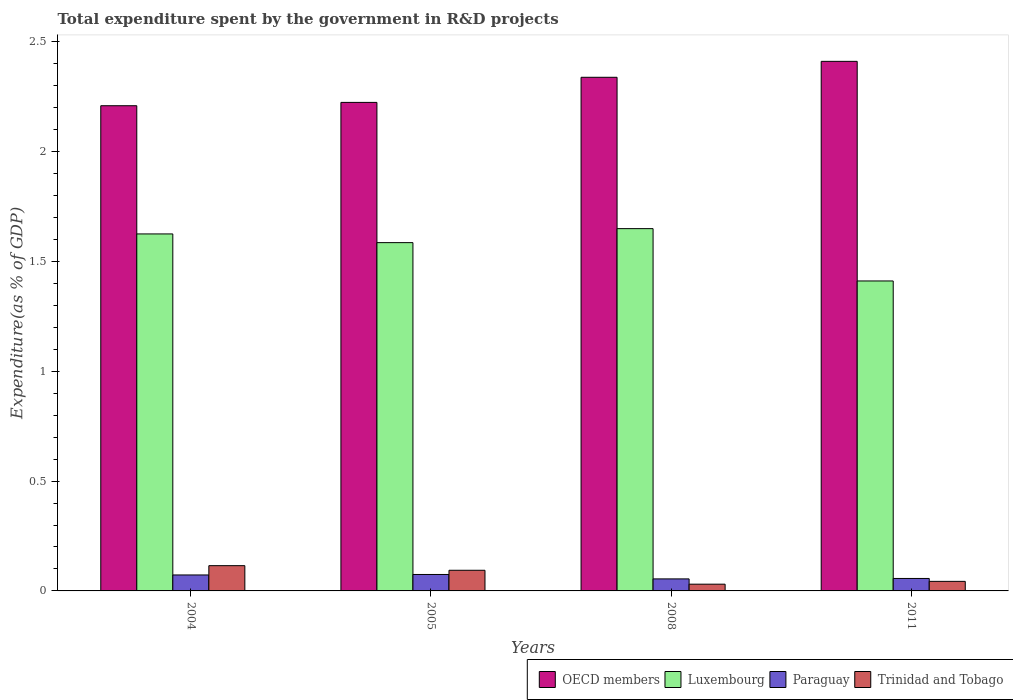How many different coloured bars are there?
Offer a very short reply. 4. How many groups of bars are there?
Your answer should be very brief. 4. How many bars are there on the 1st tick from the left?
Provide a short and direct response. 4. What is the label of the 3rd group of bars from the left?
Your answer should be very brief. 2008. In how many cases, is the number of bars for a given year not equal to the number of legend labels?
Your response must be concise. 0. What is the total expenditure spent by the government in R&D projects in Trinidad and Tobago in 2011?
Offer a very short reply. 0.04. Across all years, what is the maximum total expenditure spent by the government in R&D projects in Trinidad and Tobago?
Make the answer very short. 0.11. Across all years, what is the minimum total expenditure spent by the government in R&D projects in Trinidad and Tobago?
Keep it short and to the point. 0.03. In which year was the total expenditure spent by the government in R&D projects in Luxembourg maximum?
Your answer should be compact. 2008. In which year was the total expenditure spent by the government in R&D projects in Luxembourg minimum?
Provide a succinct answer. 2011. What is the total total expenditure spent by the government in R&D projects in Trinidad and Tobago in the graph?
Keep it short and to the point. 0.28. What is the difference between the total expenditure spent by the government in R&D projects in Trinidad and Tobago in 2004 and that in 2008?
Make the answer very short. 0.08. What is the difference between the total expenditure spent by the government in R&D projects in Paraguay in 2005 and the total expenditure spent by the government in R&D projects in Luxembourg in 2004?
Your answer should be compact. -1.55. What is the average total expenditure spent by the government in R&D projects in Paraguay per year?
Offer a terse response. 0.06. In the year 2008, what is the difference between the total expenditure spent by the government in R&D projects in Luxembourg and total expenditure spent by the government in R&D projects in OECD members?
Provide a short and direct response. -0.69. What is the ratio of the total expenditure spent by the government in R&D projects in Trinidad and Tobago in 2005 to that in 2008?
Make the answer very short. 3.06. Is the total expenditure spent by the government in R&D projects in OECD members in 2004 less than that in 2008?
Make the answer very short. Yes. Is the difference between the total expenditure spent by the government in R&D projects in Luxembourg in 2004 and 2008 greater than the difference between the total expenditure spent by the government in R&D projects in OECD members in 2004 and 2008?
Give a very brief answer. Yes. What is the difference between the highest and the second highest total expenditure spent by the government in R&D projects in Trinidad and Tobago?
Provide a succinct answer. 0.02. What is the difference between the highest and the lowest total expenditure spent by the government in R&D projects in Trinidad and Tobago?
Keep it short and to the point. 0.08. Is it the case that in every year, the sum of the total expenditure spent by the government in R&D projects in Luxembourg and total expenditure spent by the government in R&D projects in Paraguay is greater than the sum of total expenditure spent by the government in R&D projects in OECD members and total expenditure spent by the government in R&D projects in Trinidad and Tobago?
Ensure brevity in your answer.  No. What does the 4th bar from the left in 2005 represents?
Offer a terse response. Trinidad and Tobago. What does the 2nd bar from the right in 2011 represents?
Give a very brief answer. Paraguay. How many bars are there?
Your answer should be very brief. 16. Does the graph contain any zero values?
Keep it short and to the point. No. How many legend labels are there?
Your answer should be very brief. 4. How are the legend labels stacked?
Offer a terse response. Horizontal. What is the title of the graph?
Provide a short and direct response. Total expenditure spent by the government in R&D projects. Does "Uzbekistan" appear as one of the legend labels in the graph?
Offer a very short reply. No. What is the label or title of the X-axis?
Provide a succinct answer. Years. What is the label or title of the Y-axis?
Your answer should be very brief. Expenditure(as % of GDP). What is the Expenditure(as % of GDP) in OECD members in 2004?
Your answer should be very brief. 2.21. What is the Expenditure(as % of GDP) in Luxembourg in 2004?
Your answer should be compact. 1.62. What is the Expenditure(as % of GDP) of Paraguay in 2004?
Offer a very short reply. 0.07. What is the Expenditure(as % of GDP) in Trinidad and Tobago in 2004?
Offer a very short reply. 0.11. What is the Expenditure(as % of GDP) of OECD members in 2005?
Provide a short and direct response. 2.22. What is the Expenditure(as % of GDP) of Luxembourg in 2005?
Make the answer very short. 1.59. What is the Expenditure(as % of GDP) in Paraguay in 2005?
Make the answer very short. 0.07. What is the Expenditure(as % of GDP) in Trinidad and Tobago in 2005?
Provide a succinct answer. 0.09. What is the Expenditure(as % of GDP) of OECD members in 2008?
Provide a succinct answer. 2.34. What is the Expenditure(as % of GDP) in Luxembourg in 2008?
Your answer should be compact. 1.65. What is the Expenditure(as % of GDP) in Paraguay in 2008?
Your answer should be compact. 0.05. What is the Expenditure(as % of GDP) of Trinidad and Tobago in 2008?
Your answer should be very brief. 0.03. What is the Expenditure(as % of GDP) in OECD members in 2011?
Offer a terse response. 2.41. What is the Expenditure(as % of GDP) in Luxembourg in 2011?
Your answer should be compact. 1.41. What is the Expenditure(as % of GDP) in Paraguay in 2011?
Make the answer very short. 0.06. What is the Expenditure(as % of GDP) in Trinidad and Tobago in 2011?
Keep it short and to the point. 0.04. Across all years, what is the maximum Expenditure(as % of GDP) in OECD members?
Provide a succinct answer. 2.41. Across all years, what is the maximum Expenditure(as % of GDP) of Luxembourg?
Offer a very short reply. 1.65. Across all years, what is the maximum Expenditure(as % of GDP) in Paraguay?
Offer a terse response. 0.07. Across all years, what is the maximum Expenditure(as % of GDP) of Trinidad and Tobago?
Your answer should be compact. 0.11. Across all years, what is the minimum Expenditure(as % of GDP) in OECD members?
Your answer should be compact. 2.21. Across all years, what is the minimum Expenditure(as % of GDP) of Luxembourg?
Your answer should be very brief. 1.41. Across all years, what is the minimum Expenditure(as % of GDP) of Paraguay?
Keep it short and to the point. 0.05. Across all years, what is the minimum Expenditure(as % of GDP) of Trinidad and Tobago?
Provide a succinct answer. 0.03. What is the total Expenditure(as % of GDP) of OECD members in the graph?
Give a very brief answer. 9.18. What is the total Expenditure(as % of GDP) of Luxembourg in the graph?
Provide a succinct answer. 6.27. What is the total Expenditure(as % of GDP) in Paraguay in the graph?
Your response must be concise. 0.26. What is the total Expenditure(as % of GDP) of Trinidad and Tobago in the graph?
Provide a short and direct response. 0.28. What is the difference between the Expenditure(as % of GDP) of OECD members in 2004 and that in 2005?
Offer a very short reply. -0.02. What is the difference between the Expenditure(as % of GDP) in Luxembourg in 2004 and that in 2005?
Give a very brief answer. 0.04. What is the difference between the Expenditure(as % of GDP) in Paraguay in 2004 and that in 2005?
Your answer should be compact. -0. What is the difference between the Expenditure(as % of GDP) in Trinidad and Tobago in 2004 and that in 2005?
Your answer should be compact. 0.02. What is the difference between the Expenditure(as % of GDP) of OECD members in 2004 and that in 2008?
Keep it short and to the point. -0.13. What is the difference between the Expenditure(as % of GDP) in Luxembourg in 2004 and that in 2008?
Ensure brevity in your answer.  -0.02. What is the difference between the Expenditure(as % of GDP) of Paraguay in 2004 and that in 2008?
Offer a very short reply. 0.02. What is the difference between the Expenditure(as % of GDP) of Trinidad and Tobago in 2004 and that in 2008?
Your response must be concise. 0.08. What is the difference between the Expenditure(as % of GDP) of OECD members in 2004 and that in 2011?
Provide a short and direct response. -0.2. What is the difference between the Expenditure(as % of GDP) of Luxembourg in 2004 and that in 2011?
Give a very brief answer. 0.21. What is the difference between the Expenditure(as % of GDP) of Paraguay in 2004 and that in 2011?
Ensure brevity in your answer.  0.02. What is the difference between the Expenditure(as % of GDP) of Trinidad and Tobago in 2004 and that in 2011?
Keep it short and to the point. 0.07. What is the difference between the Expenditure(as % of GDP) in OECD members in 2005 and that in 2008?
Offer a terse response. -0.11. What is the difference between the Expenditure(as % of GDP) in Luxembourg in 2005 and that in 2008?
Offer a terse response. -0.06. What is the difference between the Expenditure(as % of GDP) in Paraguay in 2005 and that in 2008?
Give a very brief answer. 0.02. What is the difference between the Expenditure(as % of GDP) of Trinidad and Tobago in 2005 and that in 2008?
Offer a very short reply. 0.06. What is the difference between the Expenditure(as % of GDP) in OECD members in 2005 and that in 2011?
Provide a short and direct response. -0.19. What is the difference between the Expenditure(as % of GDP) in Luxembourg in 2005 and that in 2011?
Give a very brief answer. 0.17. What is the difference between the Expenditure(as % of GDP) in Paraguay in 2005 and that in 2011?
Offer a very short reply. 0.02. What is the difference between the Expenditure(as % of GDP) of Trinidad and Tobago in 2005 and that in 2011?
Give a very brief answer. 0.05. What is the difference between the Expenditure(as % of GDP) of OECD members in 2008 and that in 2011?
Keep it short and to the point. -0.07. What is the difference between the Expenditure(as % of GDP) of Luxembourg in 2008 and that in 2011?
Provide a short and direct response. 0.24. What is the difference between the Expenditure(as % of GDP) in Paraguay in 2008 and that in 2011?
Your answer should be compact. -0. What is the difference between the Expenditure(as % of GDP) of Trinidad and Tobago in 2008 and that in 2011?
Provide a short and direct response. -0.01. What is the difference between the Expenditure(as % of GDP) in OECD members in 2004 and the Expenditure(as % of GDP) in Luxembourg in 2005?
Offer a terse response. 0.62. What is the difference between the Expenditure(as % of GDP) in OECD members in 2004 and the Expenditure(as % of GDP) in Paraguay in 2005?
Offer a terse response. 2.13. What is the difference between the Expenditure(as % of GDP) in OECD members in 2004 and the Expenditure(as % of GDP) in Trinidad and Tobago in 2005?
Ensure brevity in your answer.  2.11. What is the difference between the Expenditure(as % of GDP) of Luxembourg in 2004 and the Expenditure(as % of GDP) of Paraguay in 2005?
Offer a very short reply. 1.55. What is the difference between the Expenditure(as % of GDP) of Luxembourg in 2004 and the Expenditure(as % of GDP) of Trinidad and Tobago in 2005?
Your answer should be very brief. 1.53. What is the difference between the Expenditure(as % of GDP) of Paraguay in 2004 and the Expenditure(as % of GDP) of Trinidad and Tobago in 2005?
Provide a succinct answer. -0.02. What is the difference between the Expenditure(as % of GDP) of OECD members in 2004 and the Expenditure(as % of GDP) of Luxembourg in 2008?
Provide a succinct answer. 0.56. What is the difference between the Expenditure(as % of GDP) of OECD members in 2004 and the Expenditure(as % of GDP) of Paraguay in 2008?
Your answer should be compact. 2.15. What is the difference between the Expenditure(as % of GDP) in OECD members in 2004 and the Expenditure(as % of GDP) in Trinidad and Tobago in 2008?
Provide a short and direct response. 2.18. What is the difference between the Expenditure(as % of GDP) in Luxembourg in 2004 and the Expenditure(as % of GDP) in Paraguay in 2008?
Offer a very short reply. 1.57. What is the difference between the Expenditure(as % of GDP) in Luxembourg in 2004 and the Expenditure(as % of GDP) in Trinidad and Tobago in 2008?
Ensure brevity in your answer.  1.59. What is the difference between the Expenditure(as % of GDP) of Paraguay in 2004 and the Expenditure(as % of GDP) of Trinidad and Tobago in 2008?
Ensure brevity in your answer.  0.04. What is the difference between the Expenditure(as % of GDP) in OECD members in 2004 and the Expenditure(as % of GDP) in Luxembourg in 2011?
Your response must be concise. 0.8. What is the difference between the Expenditure(as % of GDP) in OECD members in 2004 and the Expenditure(as % of GDP) in Paraguay in 2011?
Offer a very short reply. 2.15. What is the difference between the Expenditure(as % of GDP) in OECD members in 2004 and the Expenditure(as % of GDP) in Trinidad and Tobago in 2011?
Give a very brief answer. 2.17. What is the difference between the Expenditure(as % of GDP) of Luxembourg in 2004 and the Expenditure(as % of GDP) of Paraguay in 2011?
Your response must be concise. 1.57. What is the difference between the Expenditure(as % of GDP) of Luxembourg in 2004 and the Expenditure(as % of GDP) of Trinidad and Tobago in 2011?
Your answer should be compact. 1.58. What is the difference between the Expenditure(as % of GDP) in Paraguay in 2004 and the Expenditure(as % of GDP) in Trinidad and Tobago in 2011?
Keep it short and to the point. 0.03. What is the difference between the Expenditure(as % of GDP) of OECD members in 2005 and the Expenditure(as % of GDP) of Luxembourg in 2008?
Keep it short and to the point. 0.57. What is the difference between the Expenditure(as % of GDP) in OECD members in 2005 and the Expenditure(as % of GDP) in Paraguay in 2008?
Make the answer very short. 2.17. What is the difference between the Expenditure(as % of GDP) in OECD members in 2005 and the Expenditure(as % of GDP) in Trinidad and Tobago in 2008?
Make the answer very short. 2.19. What is the difference between the Expenditure(as % of GDP) in Luxembourg in 2005 and the Expenditure(as % of GDP) in Paraguay in 2008?
Provide a short and direct response. 1.53. What is the difference between the Expenditure(as % of GDP) in Luxembourg in 2005 and the Expenditure(as % of GDP) in Trinidad and Tobago in 2008?
Your answer should be compact. 1.55. What is the difference between the Expenditure(as % of GDP) of Paraguay in 2005 and the Expenditure(as % of GDP) of Trinidad and Tobago in 2008?
Offer a very short reply. 0.04. What is the difference between the Expenditure(as % of GDP) of OECD members in 2005 and the Expenditure(as % of GDP) of Luxembourg in 2011?
Ensure brevity in your answer.  0.81. What is the difference between the Expenditure(as % of GDP) in OECD members in 2005 and the Expenditure(as % of GDP) in Paraguay in 2011?
Offer a very short reply. 2.17. What is the difference between the Expenditure(as % of GDP) in OECD members in 2005 and the Expenditure(as % of GDP) in Trinidad and Tobago in 2011?
Ensure brevity in your answer.  2.18. What is the difference between the Expenditure(as % of GDP) of Luxembourg in 2005 and the Expenditure(as % of GDP) of Paraguay in 2011?
Offer a very short reply. 1.53. What is the difference between the Expenditure(as % of GDP) of Luxembourg in 2005 and the Expenditure(as % of GDP) of Trinidad and Tobago in 2011?
Keep it short and to the point. 1.54. What is the difference between the Expenditure(as % of GDP) of Paraguay in 2005 and the Expenditure(as % of GDP) of Trinidad and Tobago in 2011?
Your response must be concise. 0.03. What is the difference between the Expenditure(as % of GDP) of OECD members in 2008 and the Expenditure(as % of GDP) of Luxembourg in 2011?
Offer a terse response. 0.93. What is the difference between the Expenditure(as % of GDP) in OECD members in 2008 and the Expenditure(as % of GDP) in Paraguay in 2011?
Provide a short and direct response. 2.28. What is the difference between the Expenditure(as % of GDP) in OECD members in 2008 and the Expenditure(as % of GDP) in Trinidad and Tobago in 2011?
Ensure brevity in your answer.  2.29. What is the difference between the Expenditure(as % of GDP) of Luxembourg in 2008 and the Expenditure(as % of GDP) of Paraguay in 2011?
Ensure brevity in your answer.  1.59. What is the difference between the Expenditure(as % of GDP) of Luxembourg in 2008 and the Expenditure(as % of GDP) of Trinidad and Tobago in 2011?
Make the answer very short. 1.61. What is the difference between the Expenditure(as % of GDP) in Paraguay in 2008 and the Expenditure(as % of GDP) in Trinidad and Tobago in 2011?
Keep it short and to the point. 0.01. What is the average Expenditure(as % of GDP) of OECD members per year?
Provide a short and direct response. 2.3. What is the average Expenditure(as % of GDP) of Luxembourg per year?
Your answer should be very brief. 1.57. What is the average Expenditure(as % of GDP) in Paraguay per year?
Your answer should be very brief. 0.06. What is the average Expenditure(as % of GDP) of Trinidad and Tobago per year?
Keep it short and to the point. 0.07. In the year 2004, what is the difference between the Expenditure(as % of GDP) of OECD members and Expenditure(as % of GDP) of Luxembourg?
Ensure brevity in your answer.  0.58. In the year 2004, what is the difference between the Expenditure(as % of GDP) of OECD members and Expenditure(as % of GDP) of Paraguay?
Provide a short and direct response. 2.14. In the year 2004, what is the difference between the Expenditure(as % of GDP) of OECD members and Expenditure(as % of GDP) of Trinidad and Tobago?
Ensure brevity in your answer.  2.09. In the year 2004, what is the difference between the Expenditure(as % of GDP) of Luxembourg and Expenditure(as % of GDP) of Paraguay?
Provide a short and direct response. 1.55. In the year 2004, what is the difference between the Expenditure(as % of GDP) of Luxembourg and Expenditure(as % of GDP) of Trinidad and Tobago?
Give a very brief answer. 1.51. In the year 2004, what is the difference between the Expenditure(as % of GDP) in Paraguay and Expenditure(as % of GDP) in Trinidad and Tobago?
Provide a short and direct response. -0.04. In the year 2005, what is the difference between the Expenditure(as % of GDP) of OECD members and Expenditure(as % of GDP) of Luxembourg?
Your answer should be very brief. 0.64. In the year 2005, what is the difference between the Expenditure(as % of GDP) of OECD members and Expenditure(as % of GDP) of Paraguay?
Keep it short and to the point. 2.15. In the year 2005, what is the difference between the Expenditure(as % of GDP) in OECD members and Expenditure(as % of GDP) in Trinidad and Tobago?
Your answer should be very brief. 2.13. In the year 2005, what is the difference between the Expenditure(as % of GDP) in Luxembourg and Expenditure(as % of GDP) in Paraguay?
Make the answer very short. 1.51. In the year 2005, what is the difference between the Expenditure(as % of GDP) of Luxembourg and Expenditure(as % of GDP) of Trinidad and Tobago?
Your answer should be compact. 1.49. In the year 2005, what is the difference between the Expenditure(as % of GDP) in Paraguay and Expenditure(as % of GDP) in Trinidad and Tobago?
Your response must be concise. -0.02. In the year 2008, what is the difference between the Expenditure(as % of GDP) of OECD members and Expenditure(as % of GDP) of Luxembourg?
Ensure brevity in your answer.  0.69. In the year 2008, what is the difference between the Expenditure(as % of GDP) in OECD members and Expenditure(as % of GDP) in Paraguay?
Provide a succinct answer. 2.28. In the year 2008, what is the difference between the Expenditure(as % of GDP) of OECD members and Expenditure(as % of GDP) of Trinidad and Tobago?
Offer a terse response. 2.31. In the year 2008, what is the difference between the Expenditure(as % of GDP) of Luxembourg and Expenditure(as % of GDP) of Paraguay?
Provide a succinct answer. 1.59. In the year 2008, what is the difference between the Expenditure(as % of GDP) of Luxembourg and Expenditure(as % of GDP) of Trinidad and Tobago?
Your answer should be very brief. 1.62. In the year 2008, what is the difference between the Expenditure(as % of GDP) of Paraguay and Expenditure(as % of GDP) of Trinidad and Tobago?
Your answer should be very brief. 0.02. In the year 2011, what is the difference between the Expenditure(as % of GDP) in OECD members and Expenditure(as % of GDP) in Luxembourg?
Make the answer very short. 1. In the year 2011, what is the difference between the Expenditure(as % of GDP) of OECD members and Expenditure(as % of GDP) of Paraguay?
Provide a succinct answer. 2.35. In the year 2011, what is the difference between the Expenditure(as % of GDP) in OECD members and Expenditure(as % of GDP) in Trinidad and Tobago?
Ensure brevity in your answer.  2.37. In the year 2011, what is the difference between the Expenditure(as % of GDP) in Luxembourg and Expenditure(as % of GDP) in Paraguay?
Make the answer very short. 1.35. In the year 2011, what is the difference between the Expenditure(as % of GDP) in Luxembourg and Expenditure(as % of GDP) in Trinidad and Tobago?
Provide a succinct answer. 1.37. In the year 2011, what is the difference between the Expenditure(as % of GDP) in Paraguay and Expenditure(as % of GDP) in Trinidad and Tobago?
Provide a short and direct response. 0.01. What is the ratio of the Expenditure(as % of GDP) of OECD members in 2004 to that in 2005?
Keep it short and to the point. 0.99. What is the ratio of the Expenditure(as % of GDP) in Luxembourg in 2004 to that in 2005?
Provide a short and direct response. 1.02. What is the ratio of the Expenditure(as % of GDP) in Paraguay in 2004 to that in 2005?
Make the answer very short. 0.97. What is the ratio of the Expenditure(as % of GDP) in Trinidad and Tobago in 2004 to that in 2005?
Provide a succinct answer. 1.22. What is the ratio of the Expenditure(as % of GDP) of OECD members in 2004 to that in 2008?
Give a very brief answer. 0.94. What is the ratio of the Expenditure(as % of GDP) of Luxembourg in 2004 to that in 2008?
Make the answer very short. 0.99. What is the ratio of the Expenditure(as % of GDP) in Paraguay in 2004 to that in 2008?
Keep it short and to the point. 1.33. What is the ratio of the Expenditure(as % of GDP) of Trinidad and Tobago in 2004 to that in 2008?
Offer a terse response. 3.74. What is the ratio of the Expenditure(as % of GDP) in OECD members in 2004 to that in 2011?
Offer a terse response. 0.92. What is the ratio of the Expenditure(as % of GDP) of Luxembourg in 2004 to that in 2011?
Provide a succinct answer. 1.15. What is the ratio of the Expenditure(as % of GDP) of Paraguay in 2004 to that in 2011?
Keep it short and to the point. 1.28. What is the ratio of the Expenditure(as % of GDP) of Trinidad and Tobago in 2004 to that in 2011?
Ensure brevity in your answer.  2.64. What is the ratio of the Expenditure(as % of GDP) of OECD members in 2005 to that in 2008?
Your answer should be compact. 0.95. What is the ratio of the Expenditure(as % of GDP) of Luxembourg in 2005 to that in 2008?
Your answer should be very brief. 0.96. What is the ratio of the Expenditure(as % of GDP) in Paraguay in 2005 to that in 2008?
Keep it short and to the point. 1.37. What is the ratio of the Expenditure(as % of GDP) of Trinidad and Tobago in 2005 to that in 2008?
Your answer should be compact. 3.06. What is the ratio of the Expenditure(as % of GDP) in OECD members in 2005 to that in 2011?
Provide a succinct answer. 0.92. What is the ratio of the Expenditure(as % of GDP) of Luxembourg in 2005 to that in 2011?
Make the answer very short. 1.12. What is the ratio of the Expenditure(as % of GDP) in Paraguay in 2005 to that in 2011?
Offer a terse response. 1.32. What is the ratio of the Expenditure(as % of GDP) in Trinidad and Tobago in 2005 to that in 2011?
Give a very brief answer. 2.16. What is the ratio of the Expenditure(as % of GDP) of OECD members in 2008 to that in 2011?
Provide a succinct answer. 0.97. What is the ratio of the Expenditure(as % of GDP) in Luxembourg in 2008 to that in 2011?
Your answer should be very brief. 1.17. What is the ratio of the Expenditure(as % of GDP) of Paraguay in 2008 to that in 2011?
Offer a very short reply. 0.96. What is the ratio of the Expenditure(as % of GDP) in Trinidad and Tobago in 2008 to that in 2011?
Your answer should be compact. 0.71. What is the difference between the highest and the second highest Expenditure(as % of GDP) in OECD members?
Ensure brevity in your answer.  0.07. What is the difference between the highest and the second highest Expenditure(as % of GDP) in Luxembourg?
Give a very brief answer. 0.02. What is the difference between the highest and the second highest Expenditure(as % of GDP) of Paraguay?
Offer a terse response. 0. What is the difference between the highest and the second highest Expenditure(as % of GDP) of Trinidad and Tobago?
Give a very brief answer. 0.02. What is the difference between the highest and the lowest Expenditure(as % of GDP) in OECD members?
Your response must be concise. 0.2. What is the difference between the highest and the lowest Expenditure(as % of GDP) of Luxembourg?
Offer a terse response. 0.24. What is the difference between the highest and the lowest Expenditure(as % of GDP) in Paraguay?
Offer a very short reply. 0.02. What is the difference between the highest and the lowest Expenditure(as % of GDP) of Trinidad and Tobago?
Ensure brevity in your answer.  0.08. 